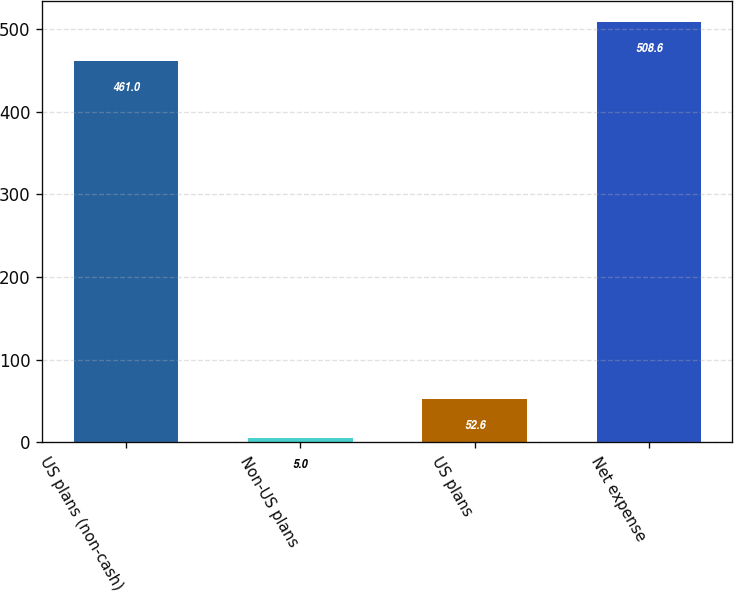Convert chart. <chart><loc_0><loc_0><loc_500><loc_500><bar_chart><fcel>US plans (non-cash)<fcel>Non-US plans<fcel>US plans<fcel>Net expense<nl><fcel>461<fcel>5<fcel>52.6<fcel>508.6<nl></chart> 